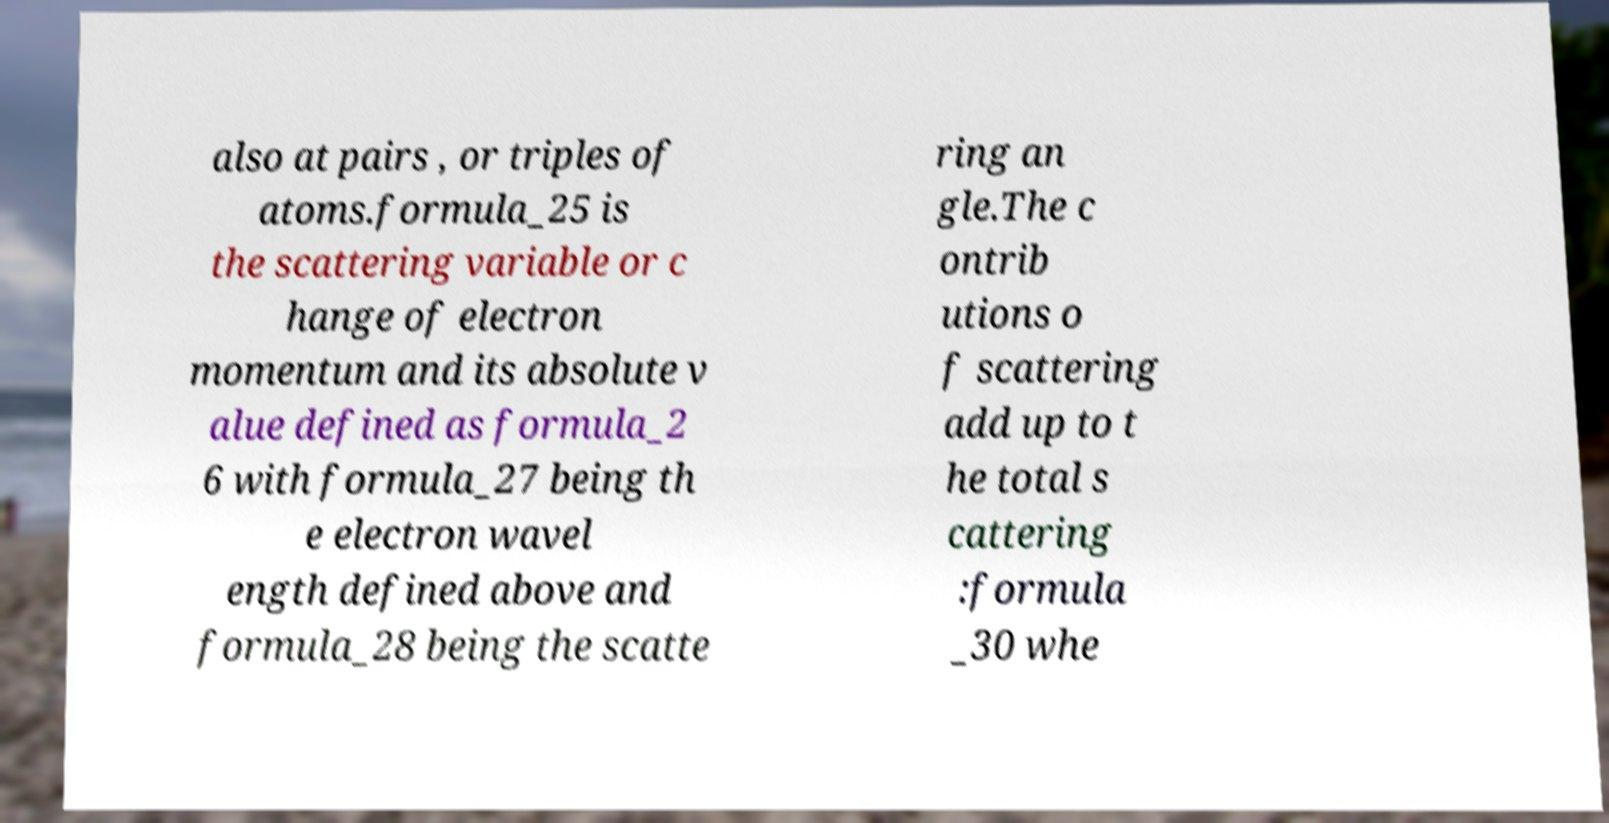Can you accurately transcribe the text from the provided image for me? also at pairs , or triples of atoms.formula_25 is the scattering variable or c hange of electron momentum and its absolute v alue defined as formula_2 6 with formula_27 being th e electron wavel ength defined above and formula_28 being the scatte ring an gle.The c ontrib utions o f scattering add up to t he total s cattering :formula _30 whe 